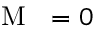<formula> <loc_0><loc_0><loc_500><loc_500>\emph { M } = 0</formula> 